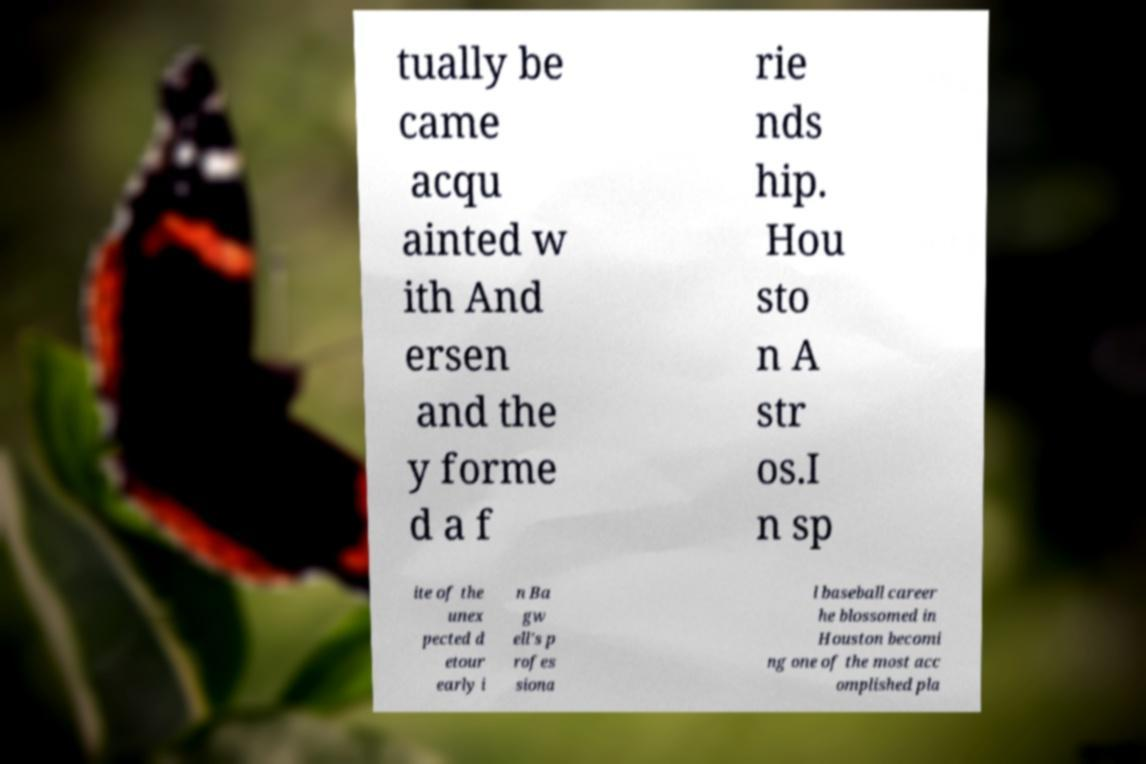What messages or text are displayed in this image? I need them in a readable, typed format. tually be came acqu ainted w ith And ersen and the y forme d a f rie nds hip. Hou sto n A str os.I n sp ite of the unex pected d etour early i n Ba gw ell's p rofes siona l baseball career he blossomed in Houston becomi ng one of the most acc omplished pla 